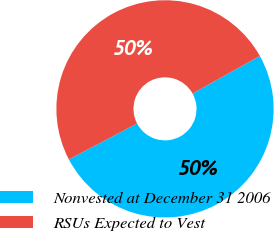Convert chart to OTSL. <chart><loc_0><loc_0><loc_500><loc_500><pie_chart><fcel>Nonvested at December 31 2006<fcel>RSUs Expected to Vest<nl><fcel>50.39%<fcel>49.61%<nl></chart> 